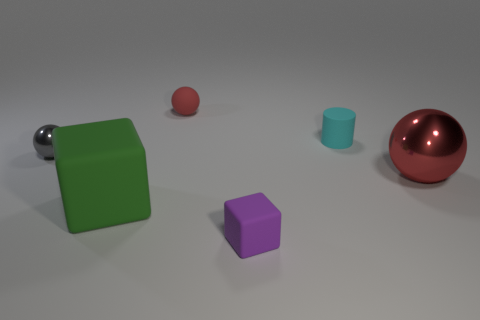Add 2 big gray matte blocks. How many objects exist? 8 Subtract all blocks. How many objects are left? 4 Add 5 big spheres. How many big spheres are left? 6 Add 3 tiny gray matte spheres. How many tiny gray matte spheres exist? 3 Subtract 0 green cylinders. How many objects are left? 6 Subtract all green metal spheres. Subtract all small red matte things. How many objects are left? 5 